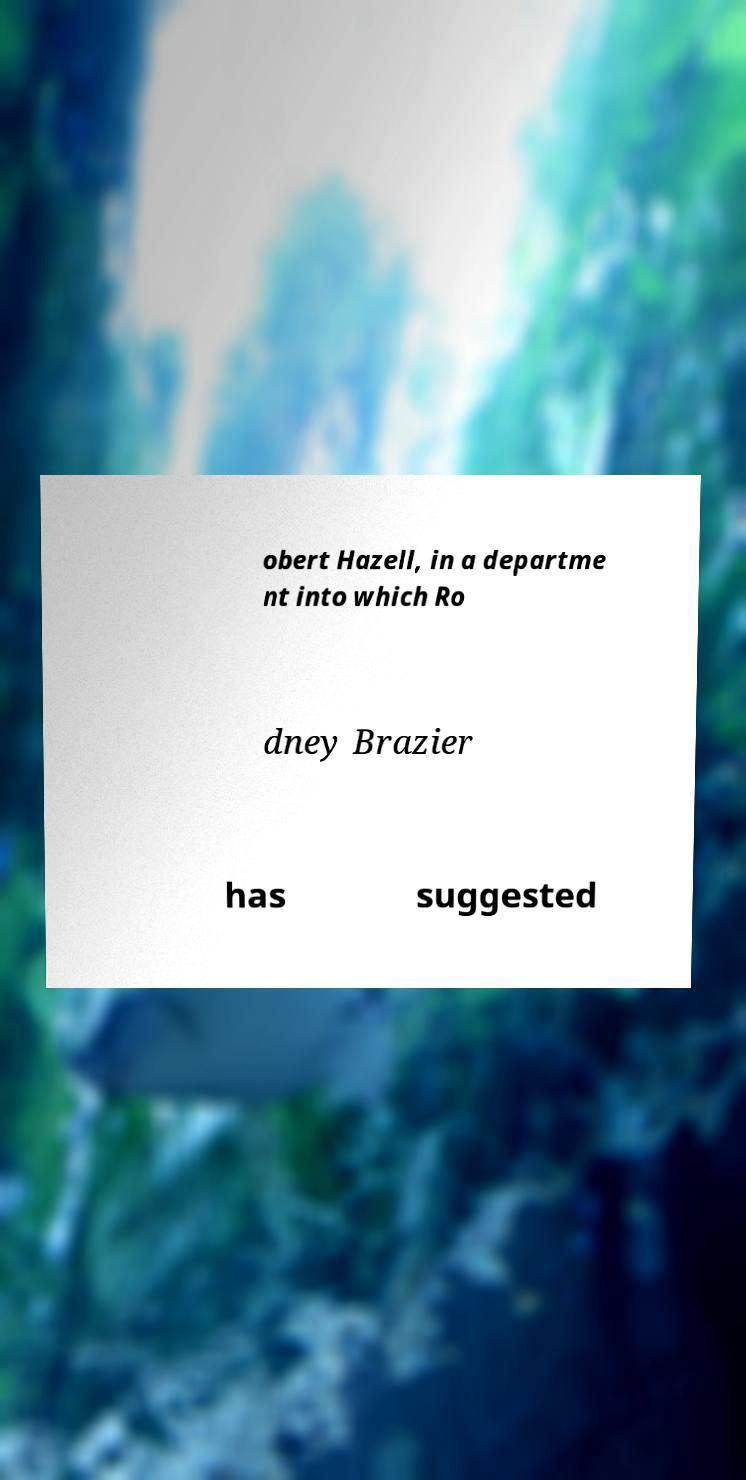Please read and relay the text visible in this image. What does it say? obert Hazell, in a departme nt into which Ro dney Brazier has suggested 